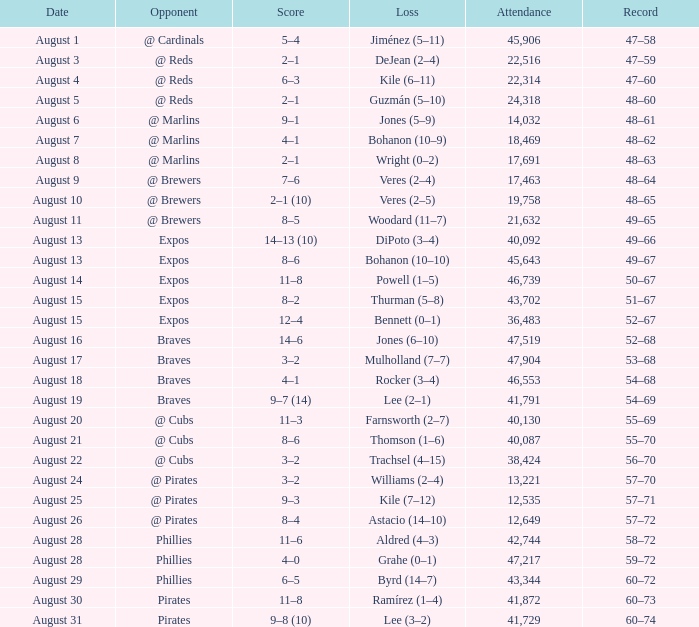What is the smallest attendance number on august 26? 12649.0. 